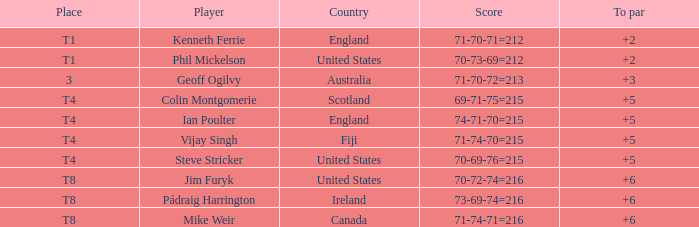What was the greatest score mike weir attained relative to par? 6.0. 